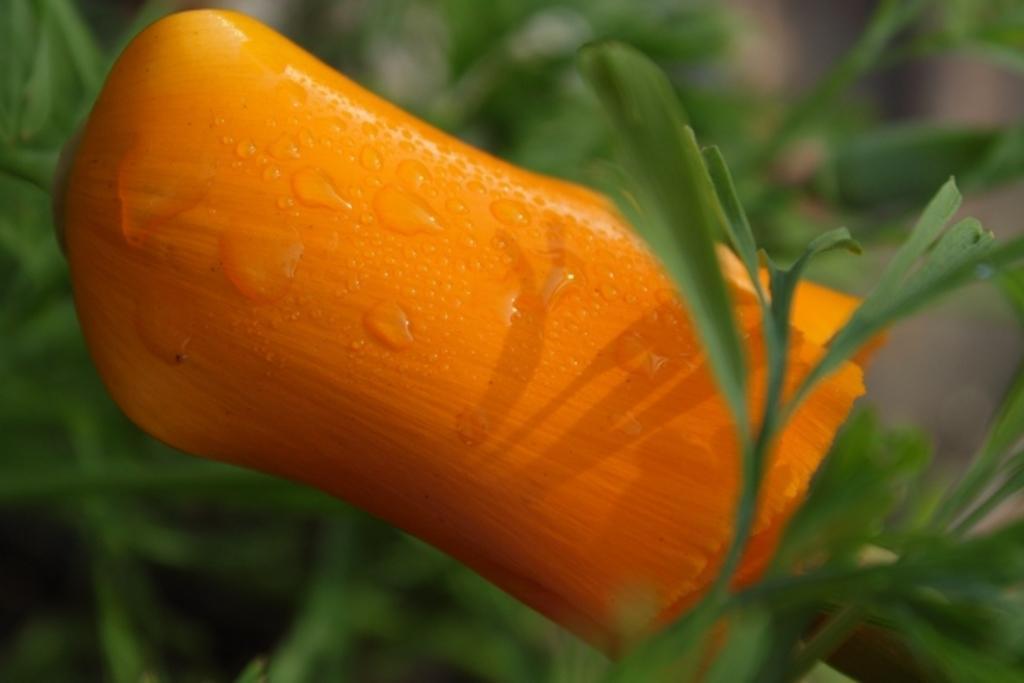Can you describe this image briefly? In this image there is a flower, around the flower there are leaves. 